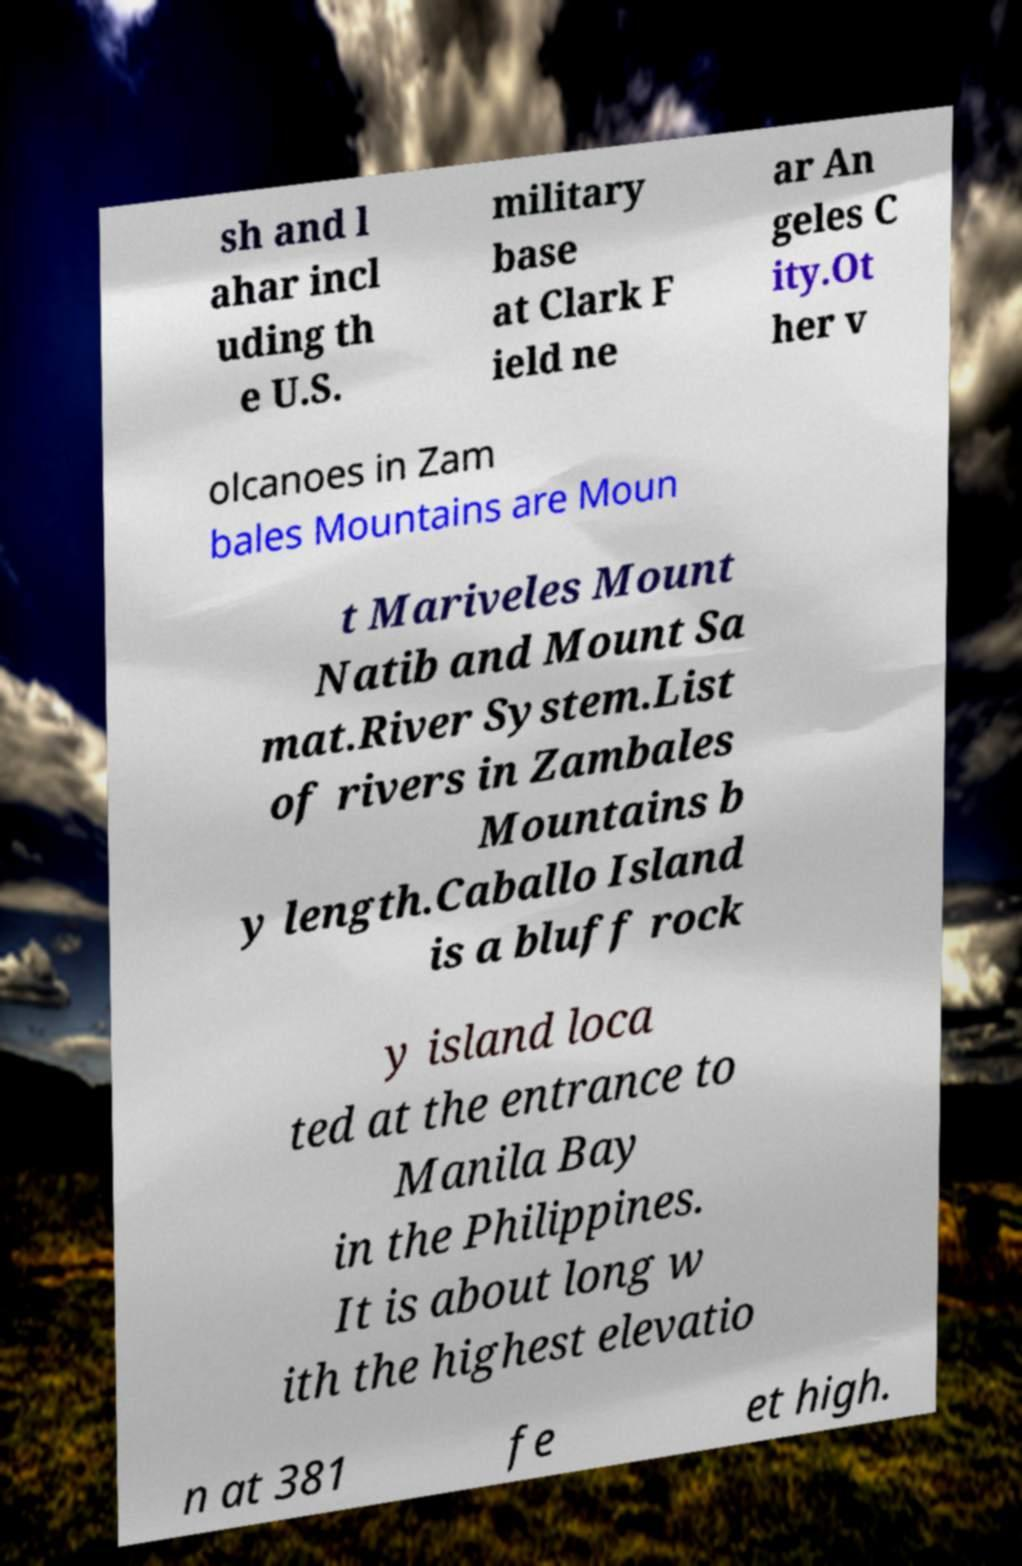Please read and relay the text visible in this image. What does it say? sh and l ahar incl uding th e U.S. military base at Clark F ield ne ar An geles C ity.Ot her v olcanoes in Zam bales Mountains are Moun t Mariveles Mount Natib and Mount Sa mat.River System.List of rivers in Zambales Mountains b y length.Caballo Island is a bluff rock y island loca ted at the entrance to Manila Bay in the Philippines. It is about long w ith the highest elevatio n at 381 fe et high. 